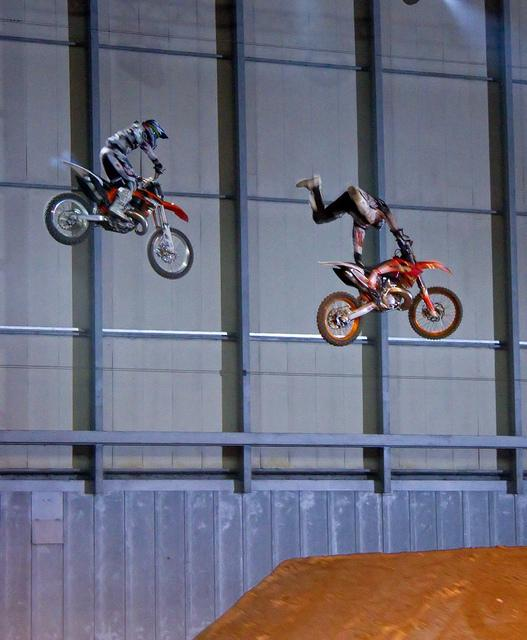What mechanism the the motorcyclists just engage? ramp 